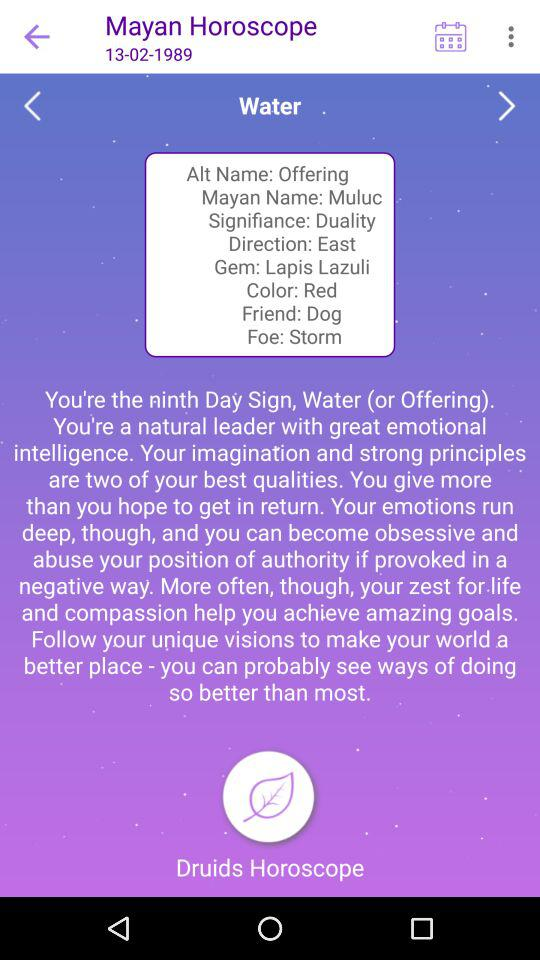What is the displayed date? The displayed date is February 13, 1989. 